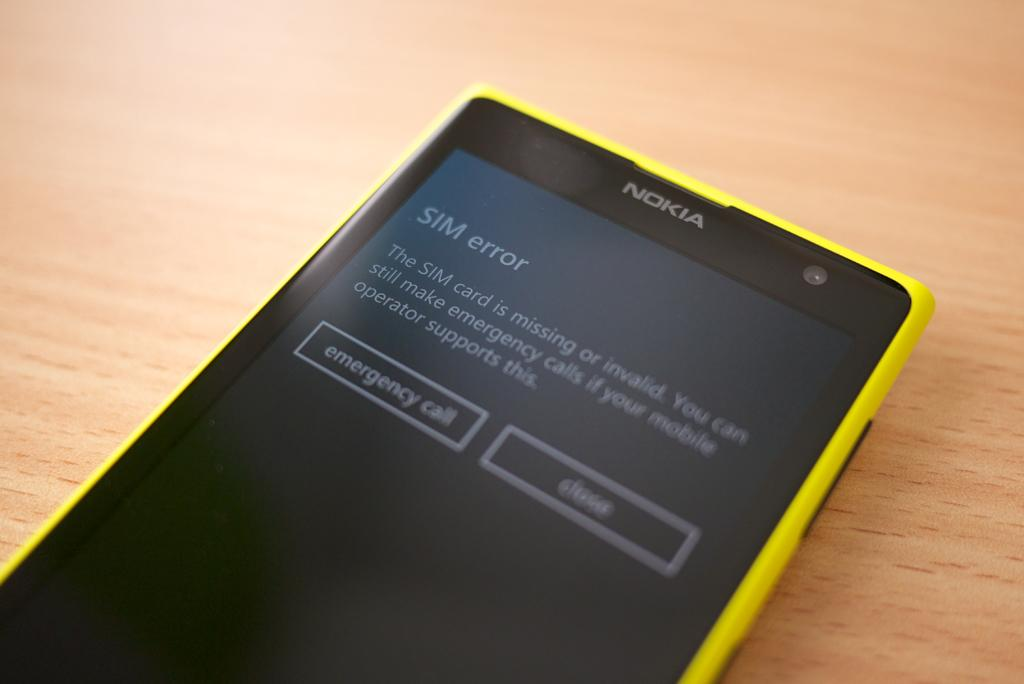<image>
Present a compact description of the photo's key features. A yellow Nokia cellphone displays a message "SIM error" 